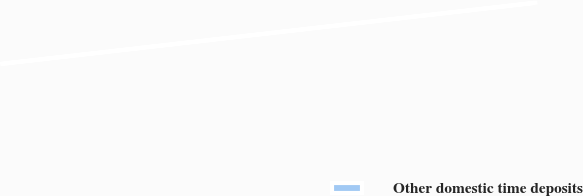Convert chart. <chart><loc_0><loc_0><loc_500><loc_500><pie_chart><fcel>Other domestic time deposits<nl><fcel>100.0%<nl></chart> 